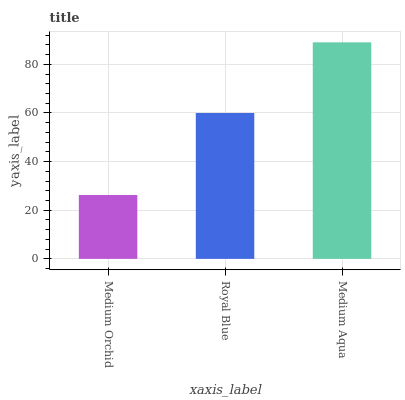Is Royal Blue the minimum?
Answer yes or no. No. Is Royal Blue the maximum?
Answer yes or no. No. Is Royal Blue greater than Medium Orchid?
Answer yes or no. Yes. Is Medium Orchid less than Royal Blue?
Answer yes or no. Yes. Is Medium Orchid greater than Royal Blue?
Answer yes or no. No. Is Royal Blue less than Medium Orchid?
Answer yes or no. No. Is Royal Blue the high median?
Answer yes or no. Yes. Is Royal Blue the low median?
Answer yes or no. Yes. Is Medium Orchid the high median?
Answer yes or no. No. Is Medium Orchid the low median?
Answer yes or no. No. 